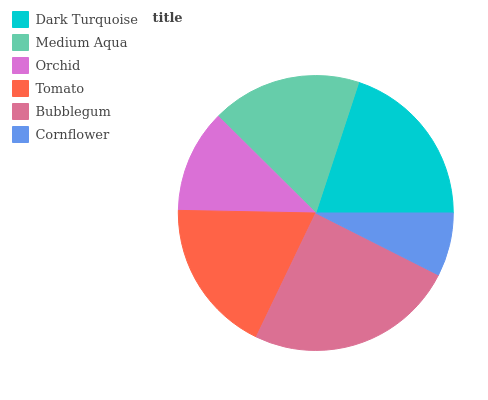Is Cornflower the minimum?
Answer yes or no. Yes. Is Bubblegum the maximum?
Answer yes or no. Yes. Is Medium Aqua the minimum?
Answer yes or no. No. Is Medium Aqua the maximum?
Answer yes or no. No. Is Dark Turquoise greater than Medium Aqua?
Answer yes or no. Yes. Is Medium Aqua less than Dark Turquoise?
Answer yes or no. Yes. Is Medium Aqua greater than Dark Turquoise?
Answer yes or no. No. Is Dark Turquoise less than Medium Aqua?
Answer yes or no. No. Is Tomato the high median?
Answer yes or no. Yes. Is Medium Aqua the low median?
Answer yes or no. Yes. Is Medium Aqua the high median?
Answer yes or no. No. Is Cornflower the low median?
Answer yes or no. No. 